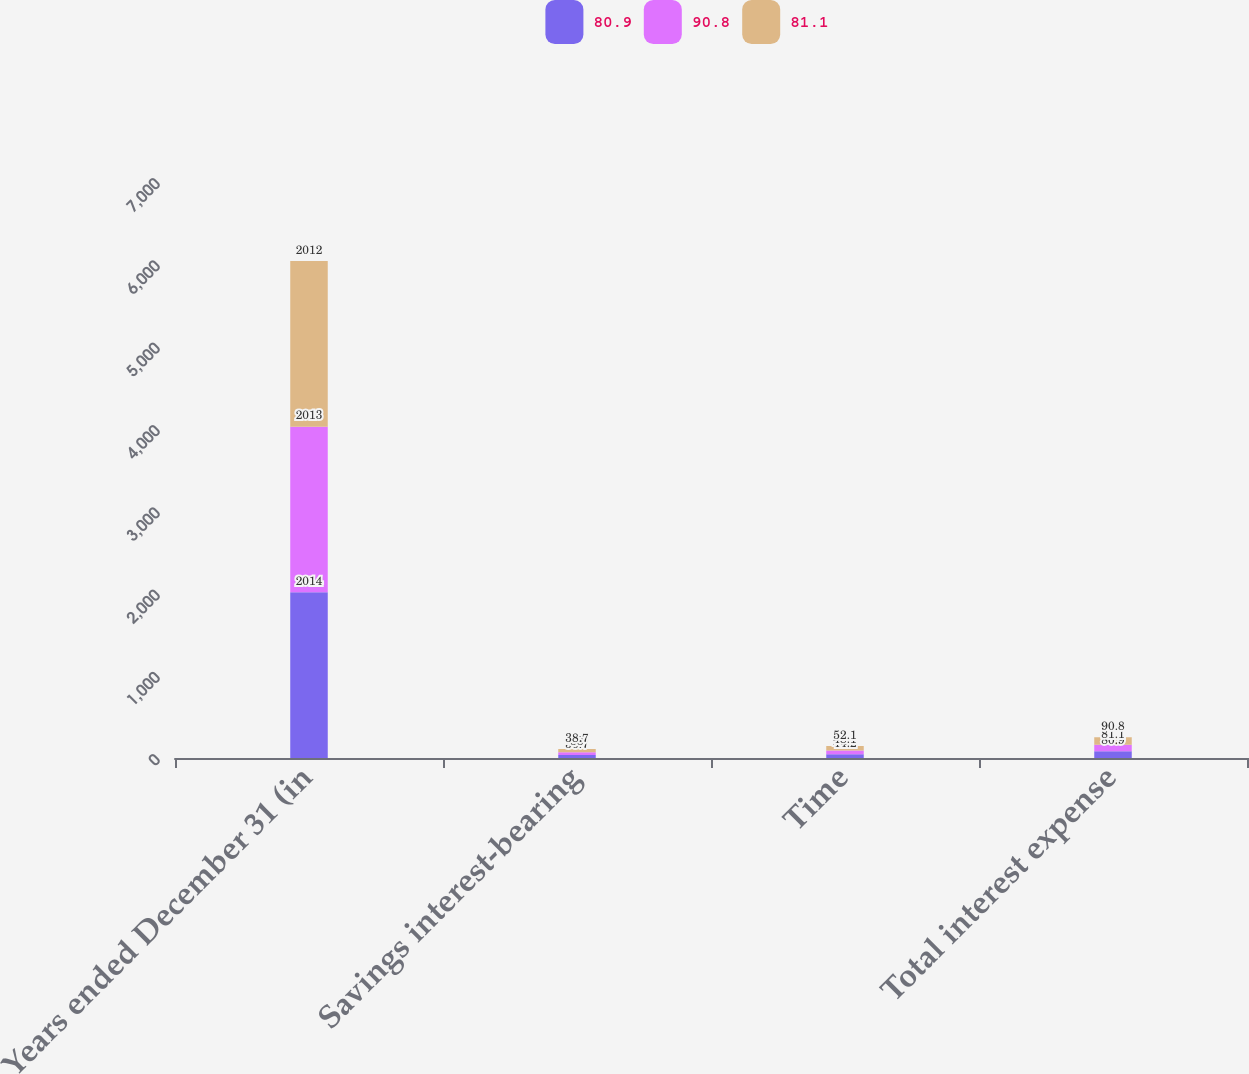Convert chart. <chart><loc_0><loc_0><loc_500><loc_500><stacked_bar_chart><ecel><fcel>Years ended December 31 (in<fcel>Savings interest-bearing<fcel>Time<fcel>Total interest expense<nl><fcel>80.9<fcel>2014<fcel>36.7<fcel>44.2<fcel>80.9<nl><fcel>90.8<fcel>2013<fcel>33<fcel>48.1<fcel>81.1<nl><fcel>81.1<fcel>2012<fcel>38.7<fcel>52.1<fcel>90.8<nl></chart> 